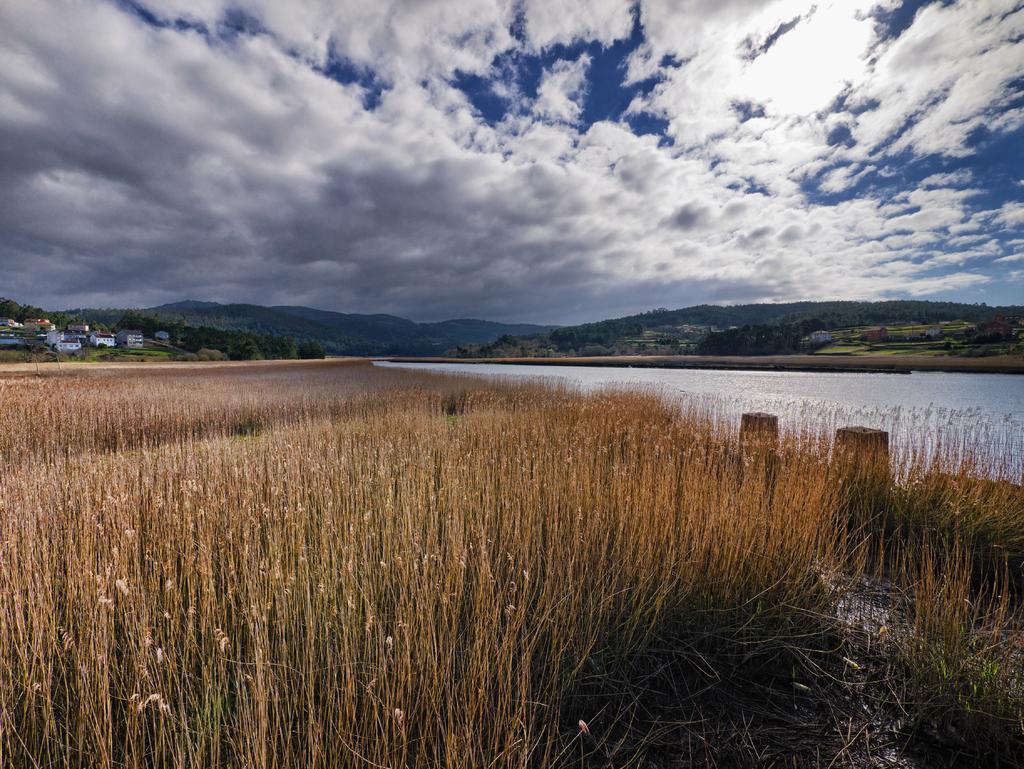Could you give a brief overview of what you see in this image? This picture is clicked outside the city. In the foreground we can see the grass and plants. In the center there is a water body and we can see the plants and many number of houses. In the background there is a sky which is full of clouds and we can see the trees and hills. 